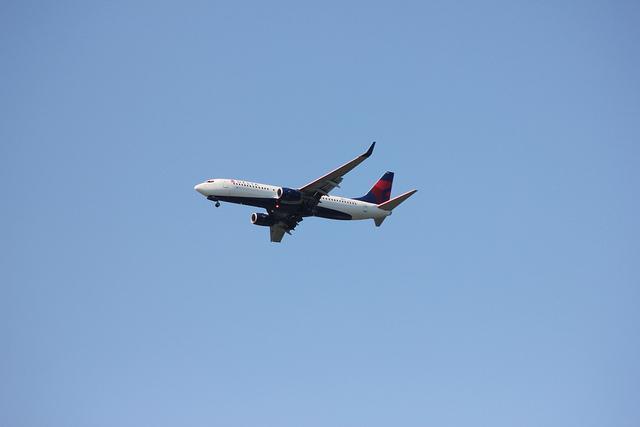How many clouds are in the sky?
Give a very brief answer. 0. 